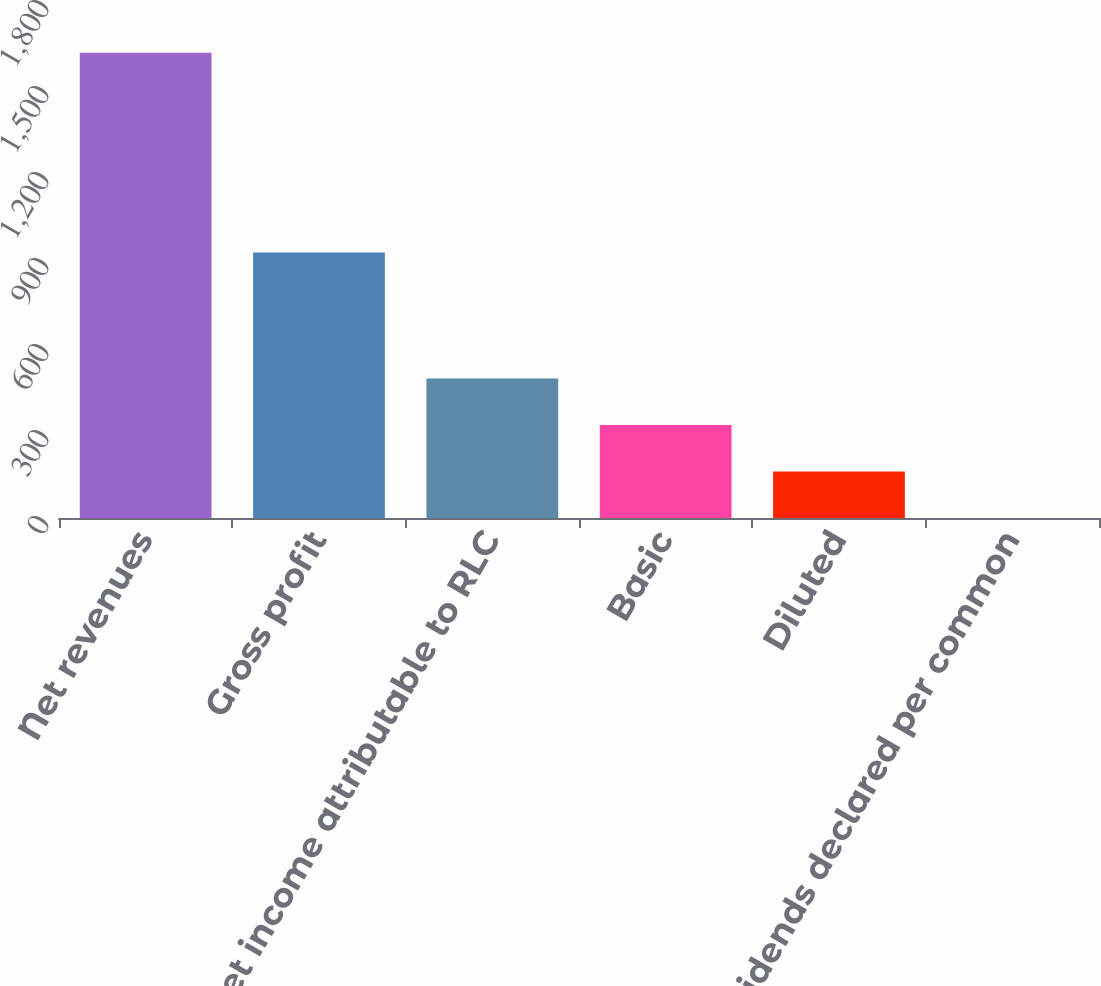<chart> <loc_0><loc_0><loc_500><loc_500><bar_chart><fcel>Net revenues<fcel>Gross profit<fcel>Net income attributable to RLC<fcel>Basic<fcel>Diluted<fcel>Dividends declared per common<nl><fcel>1622.9<fcel>926.4<fcel>487.01<fcel>324.74<fcel>162.47<fcel>0.2<nl></chart> 